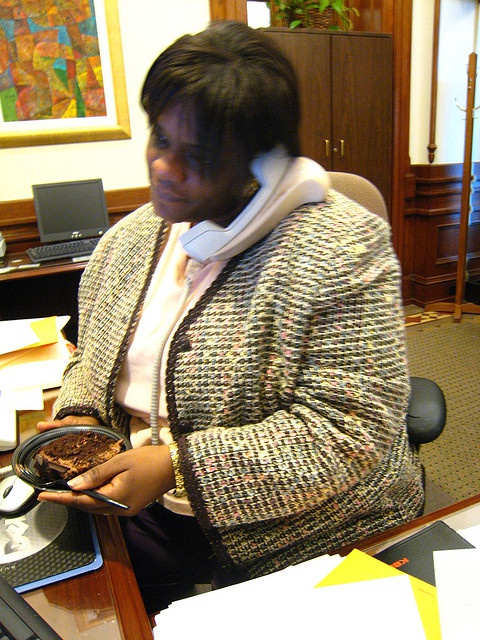Describe the objects in this image and their specific colors. I can see people in orange, black, beige, khaki, and olive tones, dining table in orange, ivory, black, maroon, and darkgreen tones, tv in orange, gray, darkgreen, and black tones, cake in orange, maroon, black, and brown tones, and chair in orange, gray, black, and darkgreen tones in this image. 